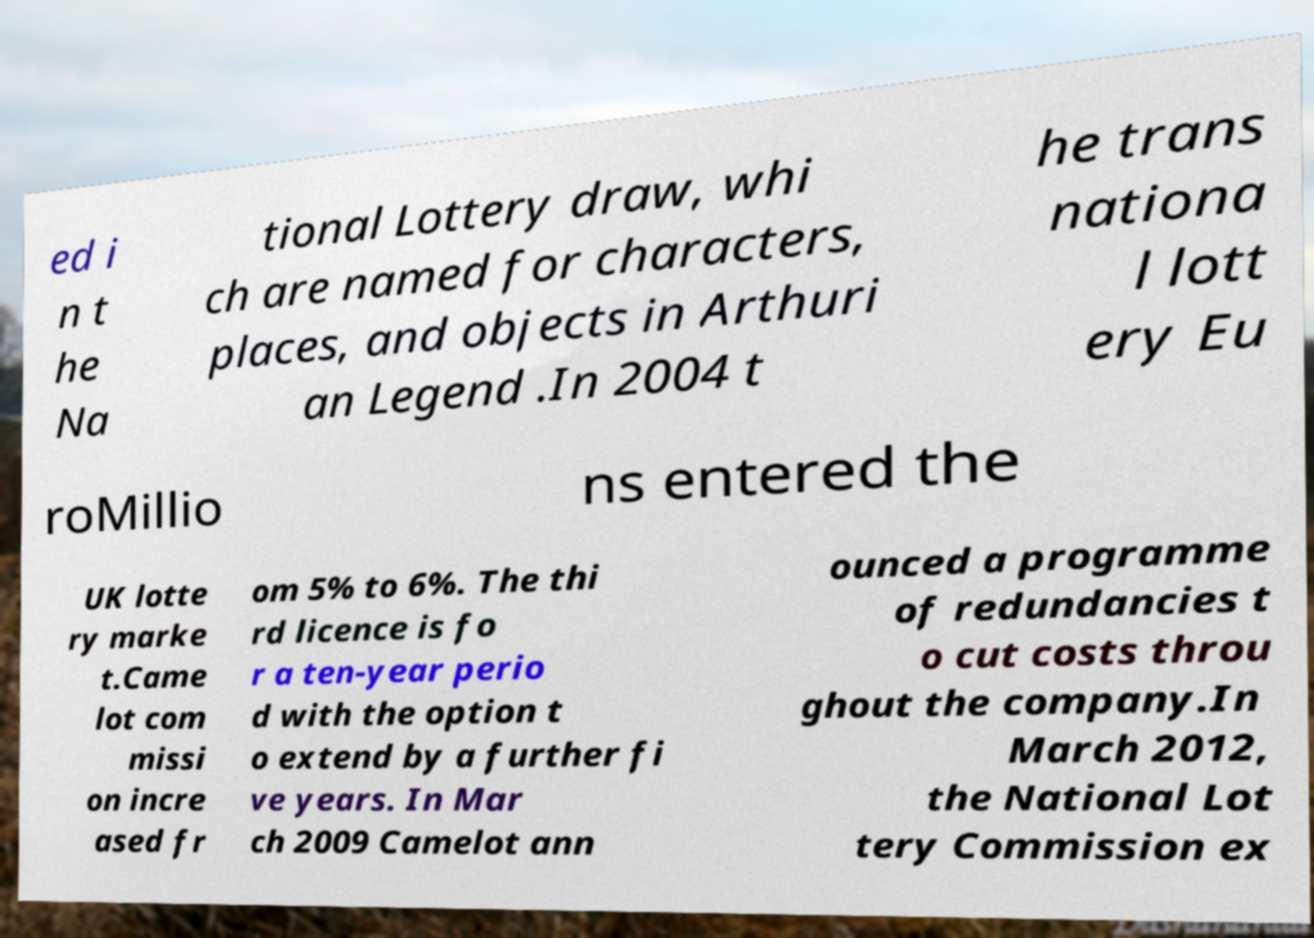Can you read and provide the text displayed in the image?This photo seems to have some interesting text. Can you extract and type it out for me? ed i n t he Na tional Lottery draw, whi ch are named for characters, places, and objects in Arthuri an Legend .In 2004 t he trans nationa l lott ery Eu roMillio ns entered the UK lotte ry marke t.Came lot com missi on incre ased fr om 5% to 6%. The thi rd licence is fo r a ten-year perio d with the option t o extend by a further fi ve years. In Mar ch 2009 Camelot ann ounced a programme of redundancies t o cut costs throu ghout the company.In March 2012, the National Lot tery Commission ex 